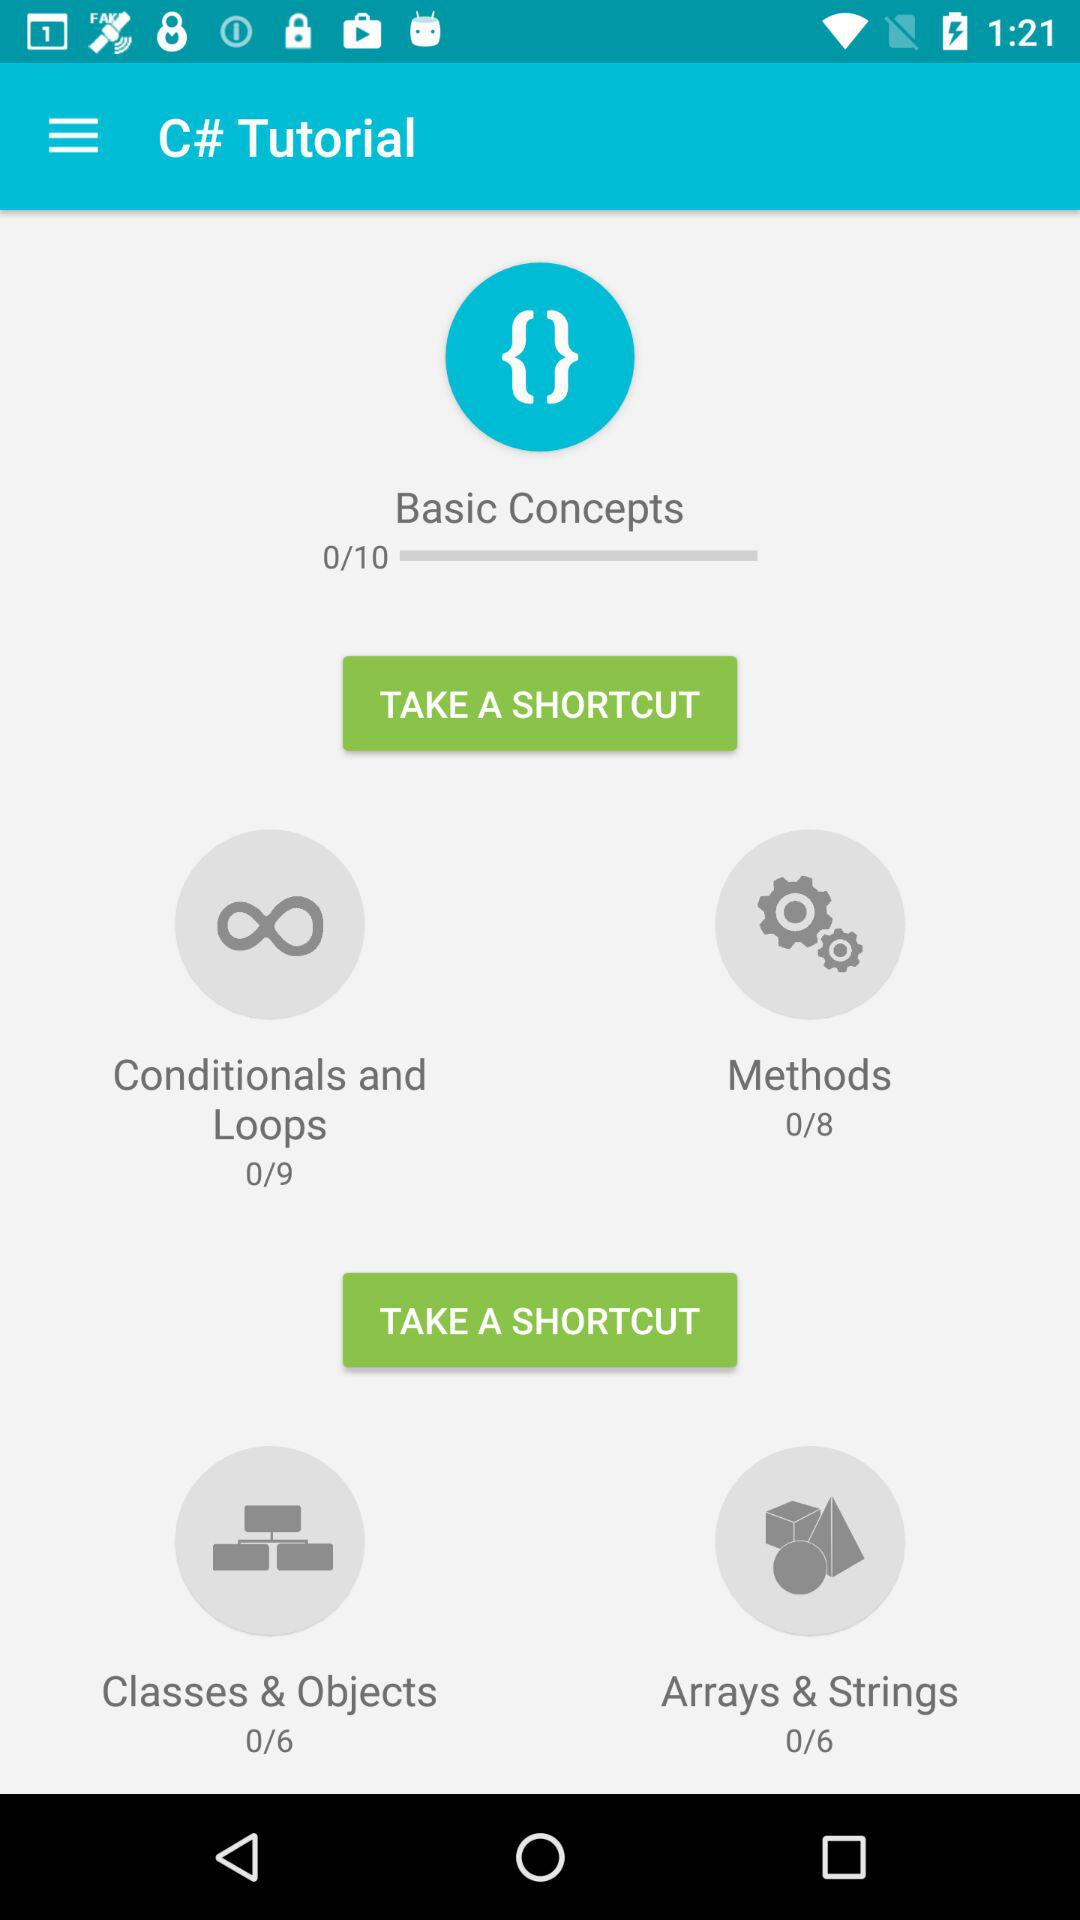How many modules in "Arrays & Strings" are there? There are 6 modules in "Arrays & Strings". 